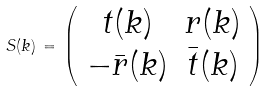Convert formula to latex. <formula><loc_0><loc_0><loc_500><loc_500>S ( k ) \, = \, \left ( \begin{array} { c c } t ( k ) & r ( k ) \\ - \bar { r } ( k ) & \bar { t } ( k ) \end{array} \right )</formula> 